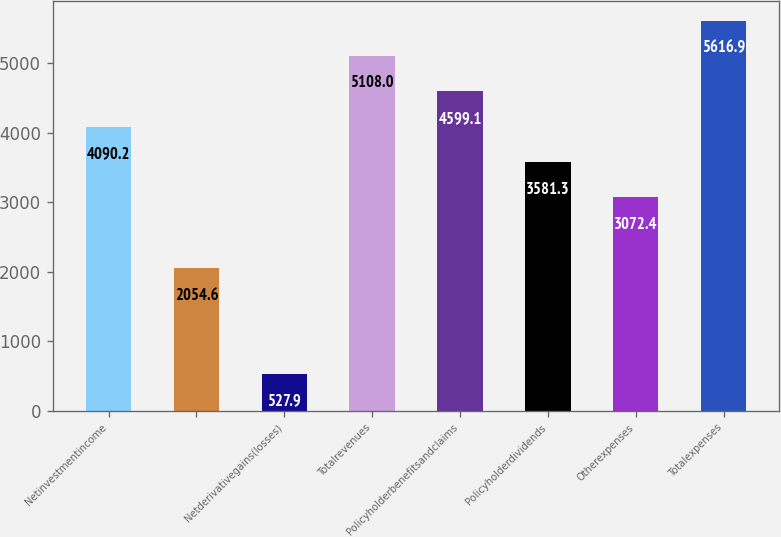Convert chart to OTSL. <chart><loc_0><loc_0><loc_500><loc_500><bar_chart><fcel>Netinvestmentincome<fcel>Unnamed: 1<fcel>Netderivativegains(losses)<fcel>Totalrevenues<fcel>Policyholderbenefitsandclaims<fcel>Policyholderdividends<fcel>Otherexpenses<fcel>Totalexpenses<nl><fcel>4090.2<fcel>2054.6<fcel>527.9<fcel>5108<fcel>4599.1<fcel>3581.3<fcel>3072.4<fcel>5616.9<nl></chart> 